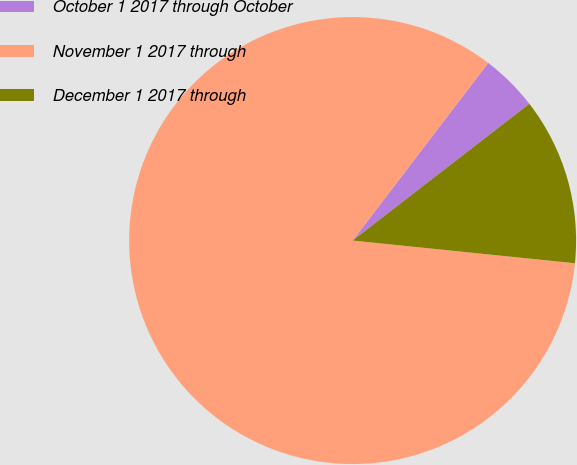Convert chart. <chart><loc_0><loc_0><loc_500><loc_500><pie_chart><fcel>October 1 2017 through October<fcel>November 1 2017 through<fcel>December 1 2017 through<nl><fcel>4.14%<fcel>83.75%<fcel>12.1%<nl></chart> 